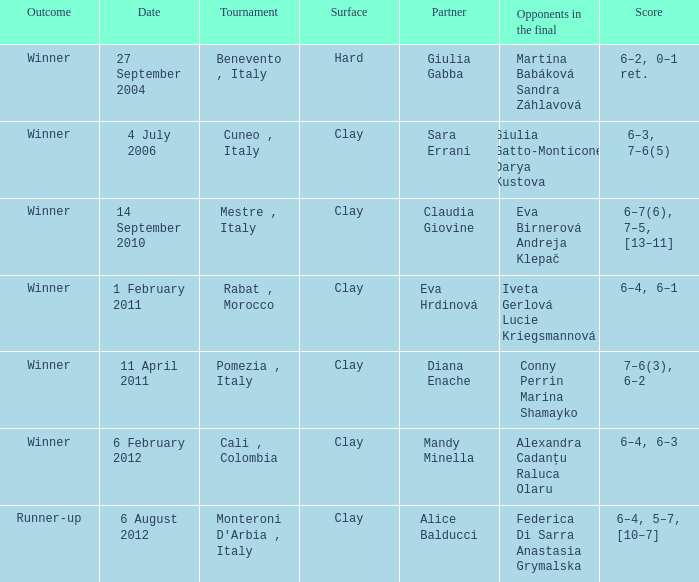Who took part on a rigid surface? Giulia Gabba. 